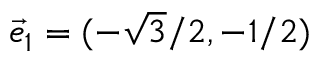Convert formula to latex. <formula><loc_0><loc_0><loc_500><loc_500>\vec { e } _ { 1 } = ( - \sqrt { 3 } / 2 , - 1 / 2 )</formula> 